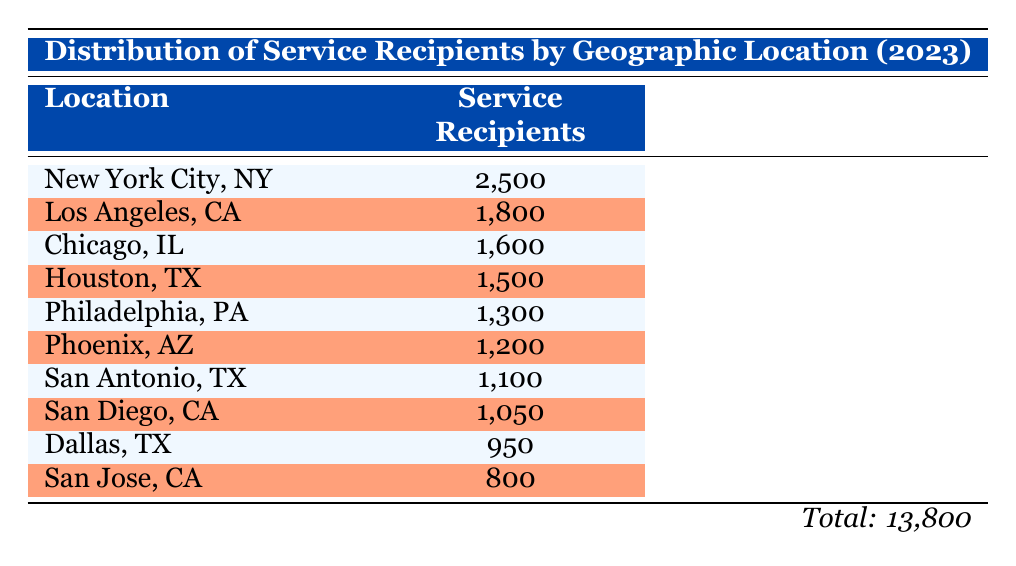What is the total number of service recipients across all locations? To find the total number of service recipients, I add the values from each location: 2500 + 1800 + 1600 + 1500 + 1300 + 1200 + 1100 + 1050 + 950 + 800 = 13800
Answer: 13800 Which location has the highest number of service recipients? By examining the list, New York City, NY has the highest figure of 2500 service recipients compared to others.
Answer: New York City, NY Is the number of service recipients in Los Angeles, CA greater than 1500? The table shows that Los Angeles, CA has 1800 service recipients, which is indeed greater than 1500.
Answer: Yes What is the average number of service recipients across the ten locations? To calculate the average, I sum the service recipients (13800 from the previous answer) and divide by the number of locations (10). Thus, 13800 / 10 = 1380.
Answer: 1380 How many service recipients do the top three locations have combined? The top three locations are New York City (2500), Los Angeles (1800), and Chicago (1600). Adding these gives 2500 + 1800 + 1600 = 5900.
Answer: 5900 Is there a location with fewer than 1000 service recipients? The table indicates San Jose, CA has 800 service recipients, which is fewer than 1000.
Answer: Yes What percentage of service recipients are from Houston, TX, relative to the total? Houston, TX has 1500 service recipients out of a total of 13800. To find the percentage, I calculate (1500 / 13800) * 100, which equals approximately 10.87%.
Answer: 10.87% How does the number of service recipients in San Diego, CA compare to that in Dallas, TX? San Diego, CA has 1050 service recipients, while Dallas, TX has 950. Comparing these values shows that San Diego has more.
Answer: San Diego, CA has more What is the difference in service recipients between the locations with the least and most recipients? The location with the least service recipients is San Jose, CA with 800 and the most is New York City, NY with 2500. The difference is 2500 - 800 = 1700.
Answer: 1700 